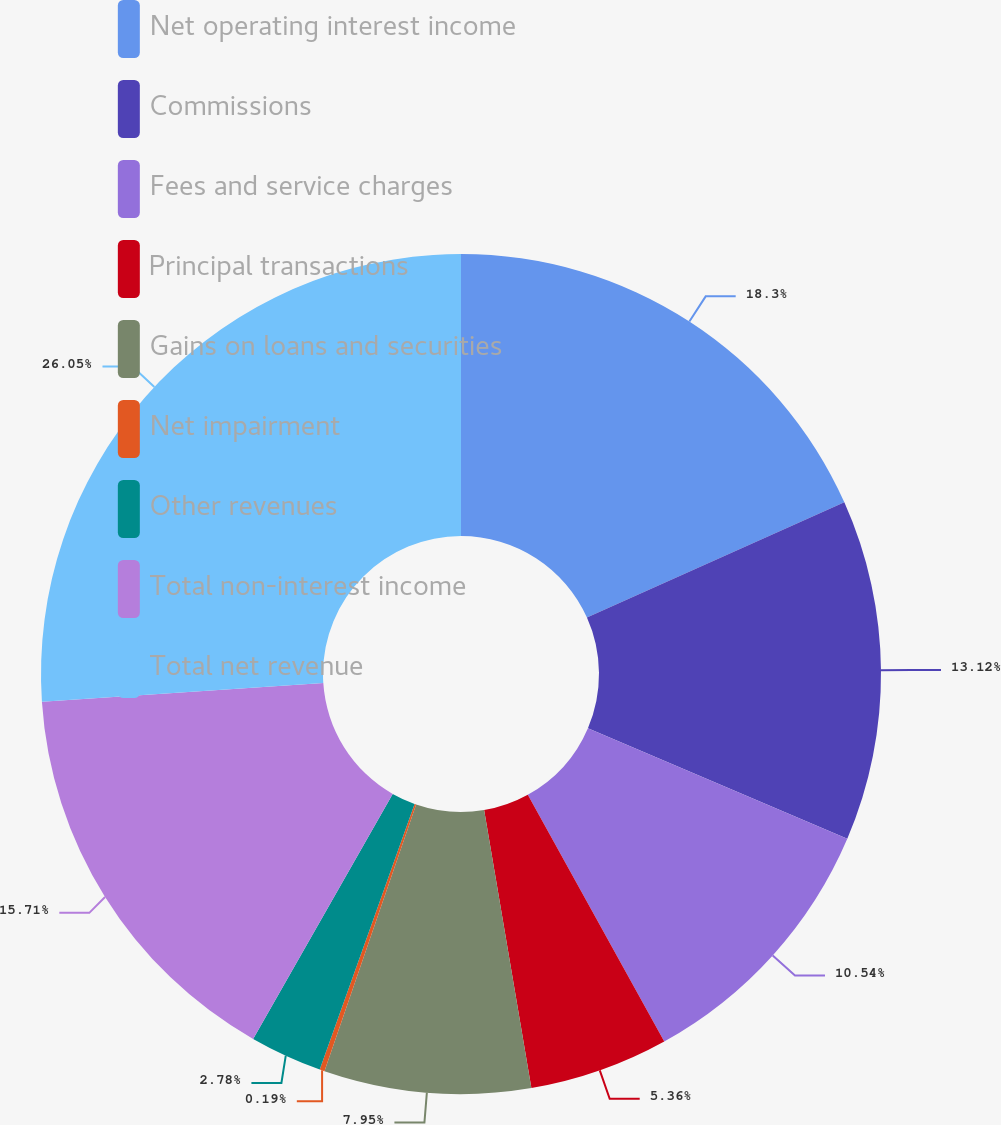Convert chart to OTSL. <chart><loc_0><loc_0><loc_500><loc_500><pie_chart><fcel>Net operating interest income<fcel>Commissions<fcel>Fees and service charges<fcel>Principal transactions<fcel>Gains on loans and securities<fcel>Net impairment<fcel>Other revenues<fcel>Total non-interest income<fcel>Total net revenue<nl><fcel>18.3%<fcel>13.12%<fcel>10.54%<fcel>5.36%<fcel>7.95%<fcel>0.19%<fcel>2.78%<fcel>15.71%<fcel>26.05%<nl></chart> 